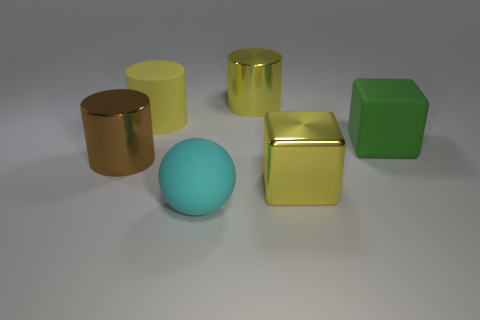Add 3 brown cylinders. How many objects exist? 9 Subtract all blocks. How many objects are left? 4 Add 2 big yellow metal cubes. How many big yellow metal cubes are left? 3 Add 5 large cyan matte objects. How many large cyan matte objects exist? 6 Subtract 0 cyan cubes. How many objects are left? 6 Subtract all yellow balls. Subtract all brown metal things. How many objects are left? 5 